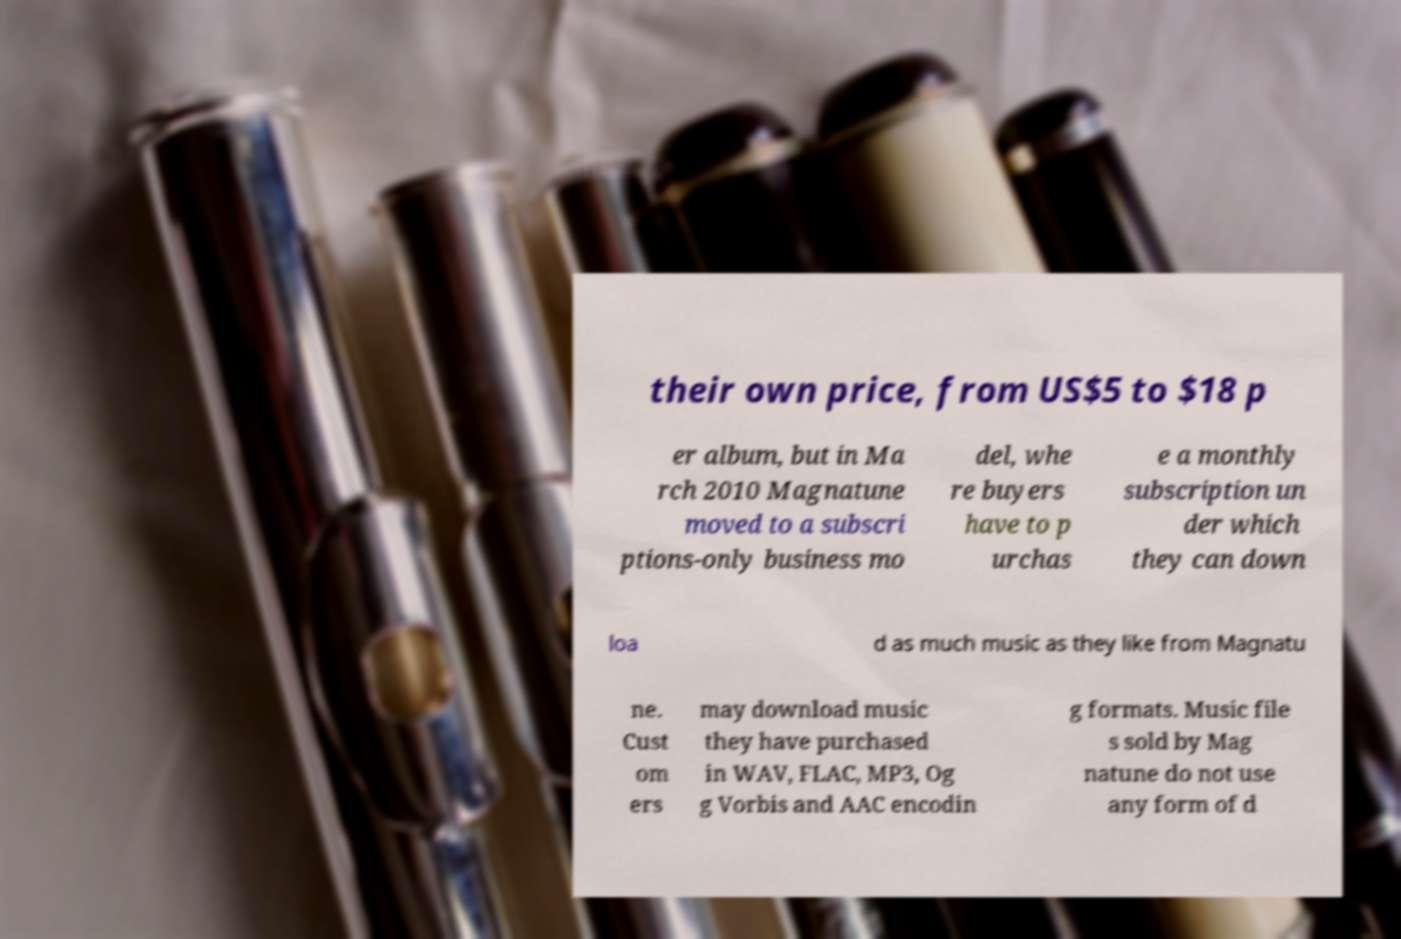Could you extract and type out the text from this image? their own price, from US$5 to $18 p er album, but in Ma rch 2010 Magnatune moved to a subscri ptions-only business mo del, whe re buyers have to p urchas e a monthly subscription un der which they can down loa d as much music as they like from Magnatu ne. Cust om ers may download music they have purchased in WAV, FLAC, MP3, Og g Vorbis and AAC encodin g formats. Music file s sold by Mag natune do not use any form of d 